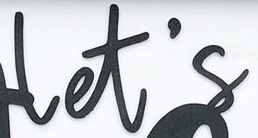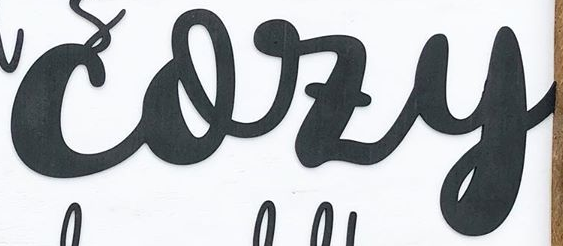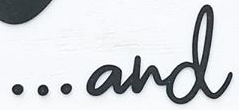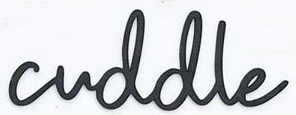Read the text from these images in sequence, separated by a semicolon. let's; cozy; ...and; cuddle 